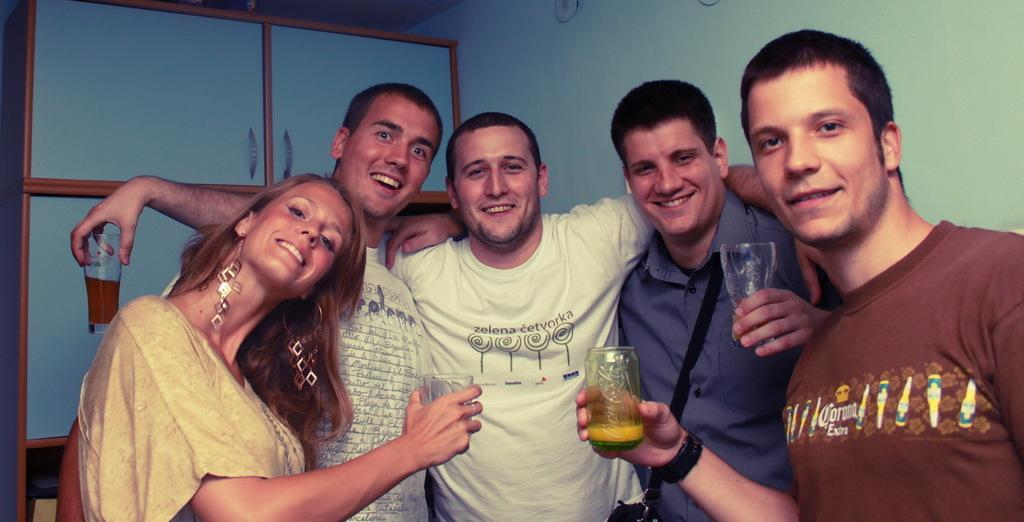Who or what can be seen in the image? There are people in the image. What are some of the people holding? Some people are holding glasses. What type of structure is visible in the image? There is a wall visible in the image. What else can be seen in the room or space? There are cupboards in the image. What type of kitty is sitting on top of the cupboards in the image? There is no kitty present on top of the cupboards in the image. 